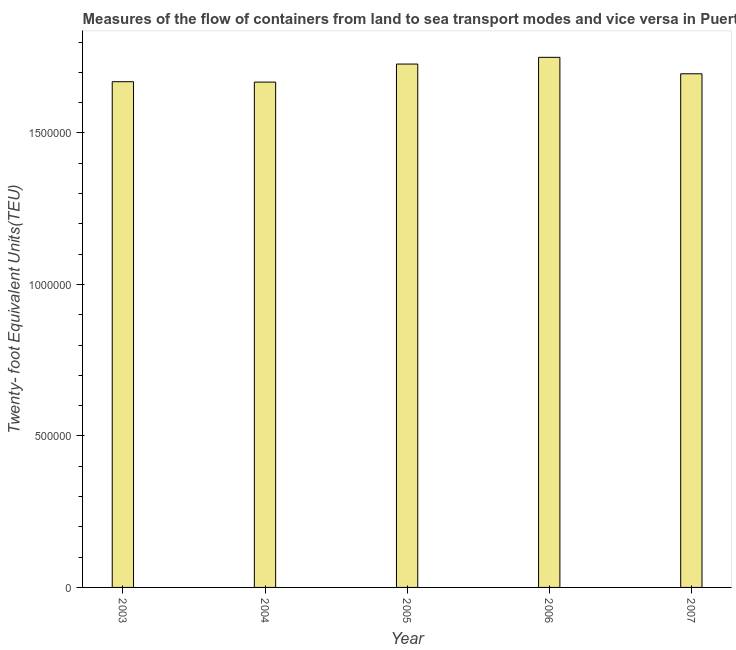What is the title of the graph?
Your answer should be compact. Measures of the flow of containers from land to sea transport modes and vice versa in Puerto Rico. What is the label or title of the Y-axis?
Your answer should be very brief. Twenty- foot Equivalent Units(TEU). What is the container port traffic in 2004?
Your response must be concise. 1.67e+06. Across all years, what is the maximum container port traffic?
Your answer should be compact. 1.75e+06. Across all years, what is the minimum container port traffic?
Offer a very short reply. 1.67e+06. In which year was the container port traffic maximum?
Make the answer very short. 2006. In which year was the container port traffic minimum?
Provide a succinct answer. 2004. What is the sum of the container port traffic?
Provide a short and direct response. 8.51e+06. What is the difference between the container port traffic in 2004 and 2006?
Offer a terse response. -8.17e+04. What is the average container port traffic per year?
Your answer should be very brief. 1.70e+06. What is the median container port traffic?
Give a very brief answer. 1.70e+06. Is the container port traffic in 2004 less than that in 2006?
Ensure brevity in your answer.  Yes. Is the difference between the container port traffic in 2003 and 2007 greater than the difference between any two years?
Offer a very short reply. No. What is the difference between the highest and the second highest container port traffic?
Offer a terse response. 2.22e+04. What is the difference between the highest and the lowest container port traffic?
Give a very brief answer. 8.17e+04. What is the difference between two consecutive major ticks on the Y-axis?
Make the answer very short. 5.00e+05. What is the Twenty- foot Equivalent Units(TEU) of 2003?
Offer a terse response. 1.67e+06. What is the Twenty- foot Equivalent Units(TEU) in 2004?
Provide a succinct answer. 1.67e+06. What is the Twenty- foot Equivalent Units(TEU) in 2005?
Provide a succinct answer. 1.73e+06. What is the Twenty- foot Equivalent Units(TEU) of 2006?
Your response must be concise. 1.75e+06. What is the Twenty- foot Equivalent Units(TEU) in 2007?
Your response must be concise. 1.70e+06. What is the difference between the Twenty- foot Equivalent Units(TEU) in 2003 and 2004?
Your answer should be very brief. 1302. What is the difference between the Twenty- foot Equivalent Units(TEU) in 2003 and 2005?
Keep it short and to the point. -5.82e+04. What is the difference between the Twenty- foot Equivalent Units(TEU) in 2003 and 2006?
Offer a terse response. -8.04e+04. What is the difference between the Twenty- foot Equivalent Units(TEU) in 2003 and 2007?
Provide a short and direct response. -2.61e+04. What is the difference between the Twenty- foot Equivalent Units(TEU) in 2004 and 2005?
Your answer should be compact. -5.95e+04. What is the difference between the Twenty- foot Equivalent Units(TEU) in 2004 and 2006?
Provide a succinct answer. -8.17e+04. What is the difference between the Twenty- foot Equivalent Units(TEU) in 2004 and 2007?
Give a very brief answer. -2.74e+04. What is the difference between the Twenty- foot Equivalent Units(TEU) in 2005 and 2006?
Give a very brief answer. -2.22e+04. What is the difference between the Twenty- foot Equivalent Units(TEU) in 2005 and 2007?
Your answer should be very brief. 3.21e+04. What is the difference between the Twenty- foot Equivalent Units(TEU) in 2006 and 2007?
Your response must be concise. 5.43e+04. What is the ratio of the Twenty- foot Equivalent Units(TEU) in 2003 to that in 2005?
Keep it short and to the point. 0.97. What is the ratio of the Twenty- foot Equivalent Units(TEU) in 2003 to that in 2006?
Provide a succinct answer. 0.95. What is the ratio of the Twenty- foot Equivalent Units(TEU) in 2004 to that in 2005?
Give a very brief answer. 0.97. What is the ratio of the Twenty- foot Equivalent Units(TEU) in 2004 to that in 2006?
Make the answer very short. 0.95. What is the ratio of the Twenty- foot Equivalent Units(TEU) in 2004 to that in 2007?
Offer a terse response. 0.98. What is the ratio of the Twenty- foot Equivalent Units(TEU) in 2005 to that in 2006?
Provide a short and direct response. 0.99. What is the ratio of the Twenty- foot Equivalent Units(TEU) in 2006 to that in 2007?
Your answer should be compact. 1.03. 